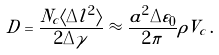<formula> <loc_0><loc_0><loc_500><loc_500>\tilde { D } = \frac { N _ { c } \langle \Delta l ^ { 2 } \rangle } { 2 \Delta \gamma } \approx \frac { a ^ { 2 } \Delta \varepsilon _ { 0 } } { 2 \pi } \rho V _ { c } \, .</formula> 